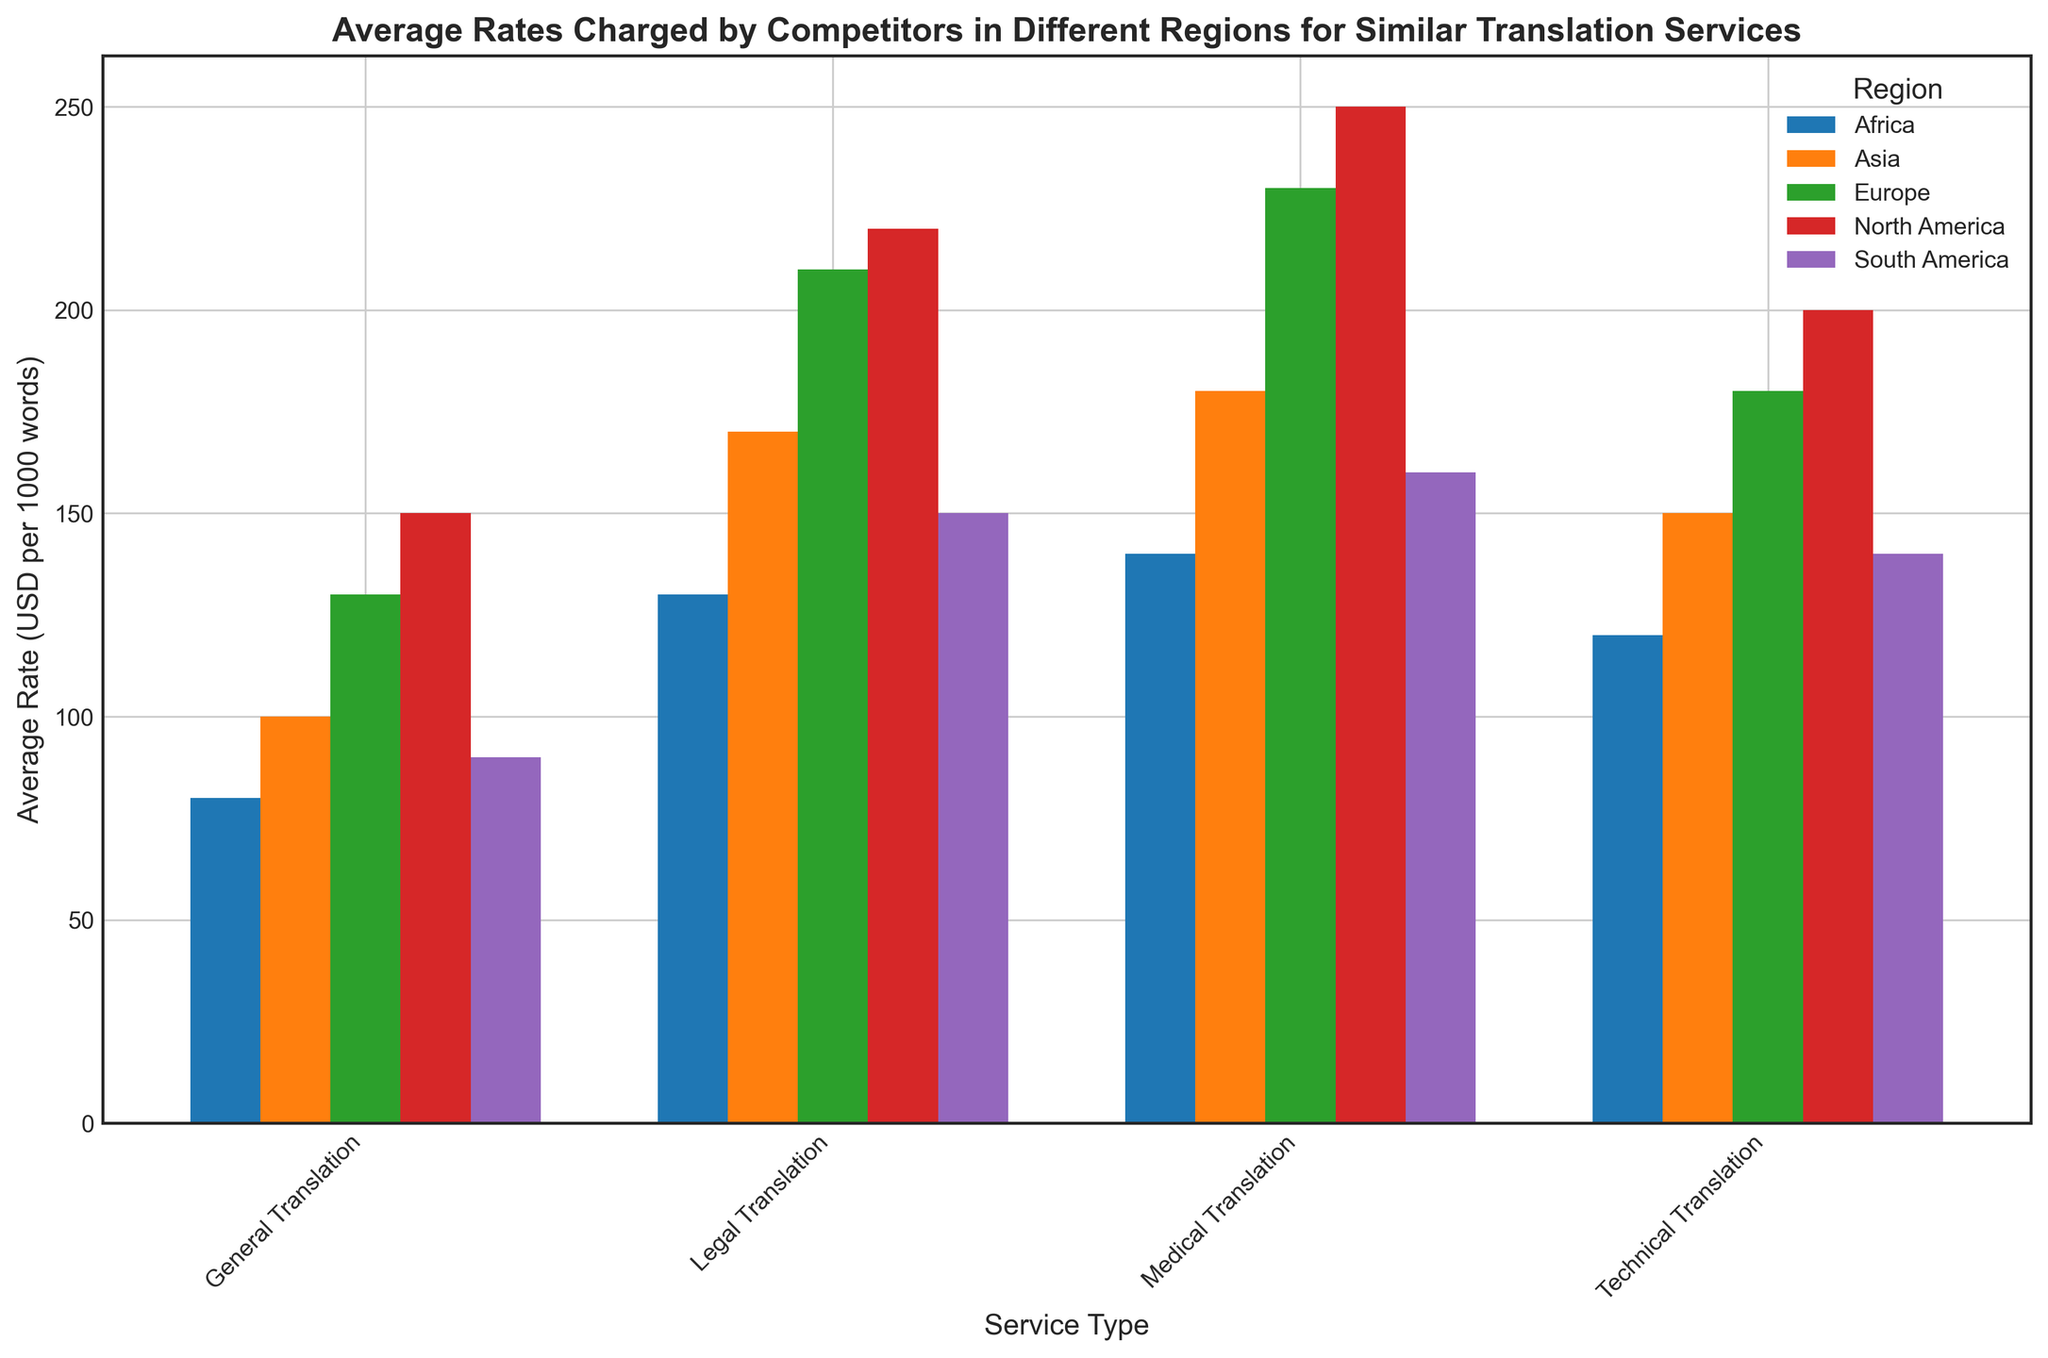what is the average rate for Medical Translation across all regions? Sum the average rates for Medical Translation in each region: 250 (North America) + 230 (Europe) + 180 (Asia) + 160 (South America) + 140 (Africa) = 960. Then divide by the number of regions, which is 5. So, 960 / 5 = 192
Answer: 192 Which region has the highest average rate for Technical Translation? Look at the bar heights for Technical Translation in all regions and identify the tallest one. North America has the highest bar, indicating the highest rate of 200 USD
Answer: North America Do General Translation services have higher rates in North America or Europe? Compare the bars for General Translation in North America and Europe. North America's rate is 150 USD while Europe's rate is 130 USD
Answer: North America What’s the difference in average rates for Legal Translation between Asia and South America? Subtract the average rate in South America from the one in Asia: 170 (Asia) - 150 (South America) = 20
Answer: 20 Which service type has the lowest average rate in Africa? Compare the heights of all bars in Africa. General Translation has the shortest bar at 80 USD
Answer: General Translation Are the average rates for General Translation higher or lower in Africa compared to Asia? Compare the General Translation bars in Africa and Asia. Africa’s rate is 80 USD, while Asia’s rate is 100 USD. So, Africa's rate is lower
Answer: Lower What is the range of average rates for Legal Translation across all regions? Identify the highest and lowest rates for Legal Translation: 220 (North America) and 130 (Africa). Subtract the lowest from the highest: 220 - 130 = 90
Answer: 90 Is the rate for Medical Translation in Europe higher or lower than the rate for Legal Translation in Europe? Compare the bars for Medical and Legal Translation in Europe. Medical Translation is 230 USD, and Legal Translation is 210 USD. Medical Translation is higher
Answer: Higher 